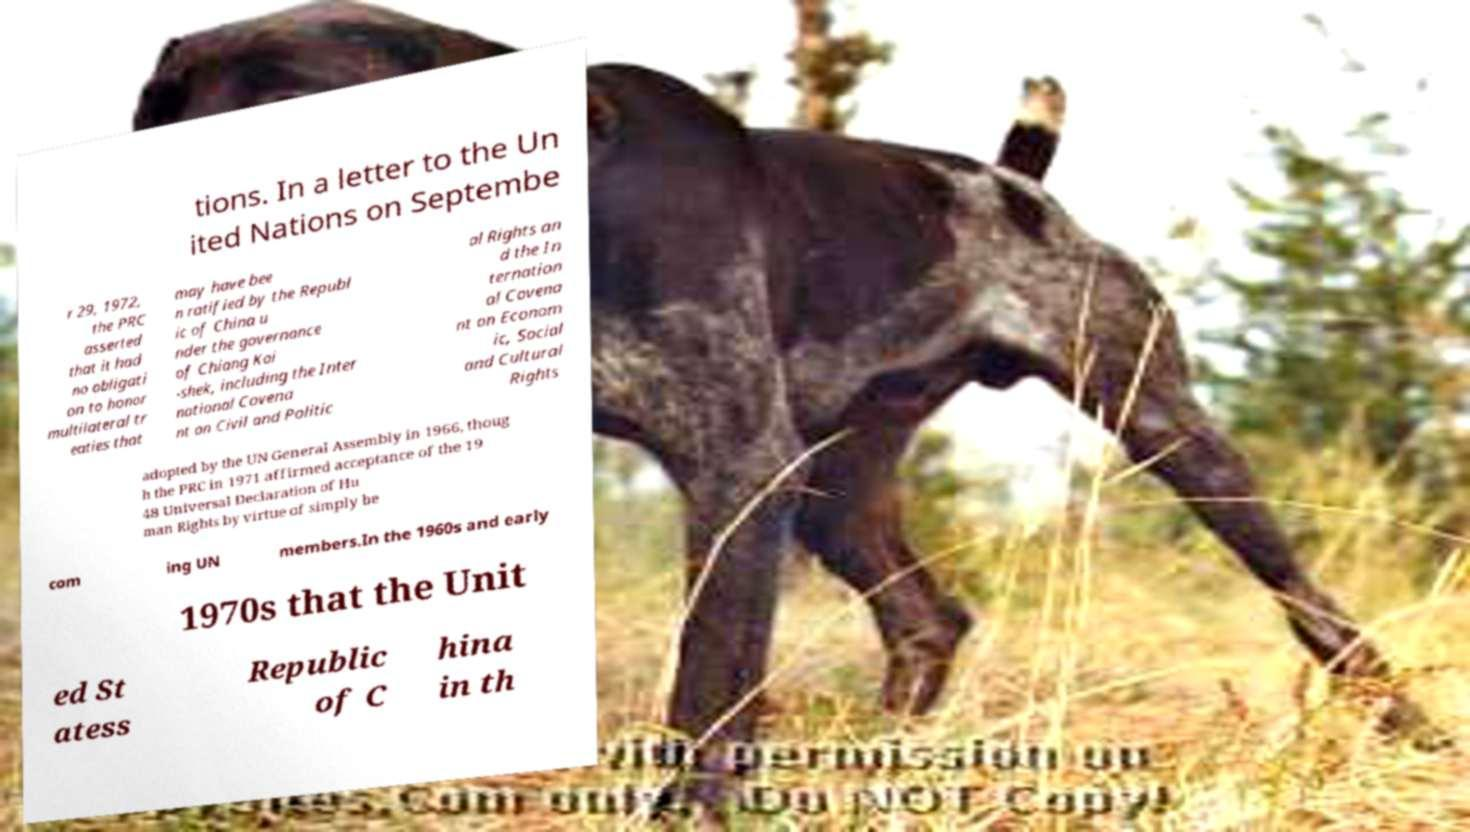Please identify and transcribe the text found in this image. tions. In a letter to the Un ited Nations on Septembe r 29, 1972, the PRC asserted that it had no obligati on to honor multilateral tr eaties that may have bee n ratified by the Republ ic of China u nder the governance of Chiang Kai -shek, including the Inter national Covena nt on Civil and Politic al Rights an d the In ternation al Covena nt on Econom ic, Social and Cultural Rights adopted by the UN General Assembly in 1966, thoug h the PRC in 1971 affirmed acceptance of the 19 48 Universal Declaration of Hu man Rights by virtue of simply be com ing UN members.In the 1960s and early 1970s that the Unit ed St atess Republic of C hina in th 